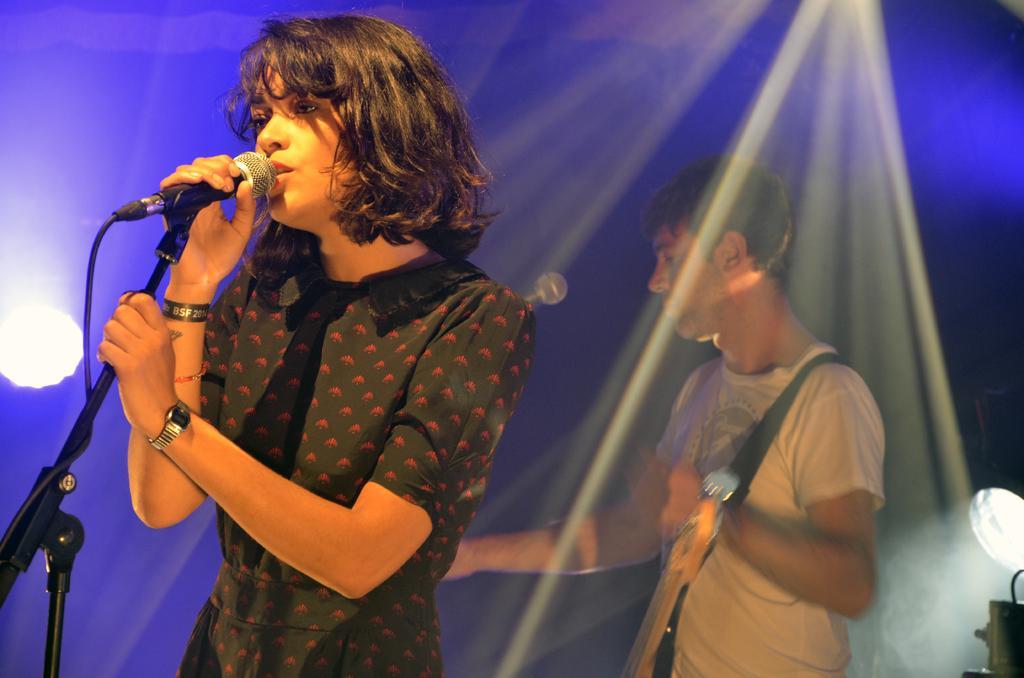Describe this image in one or two sentences. In the image there is a girl in black dress singing on mic and behind her there is a man playing guitar, there are lights over the ceiling and over the background. 